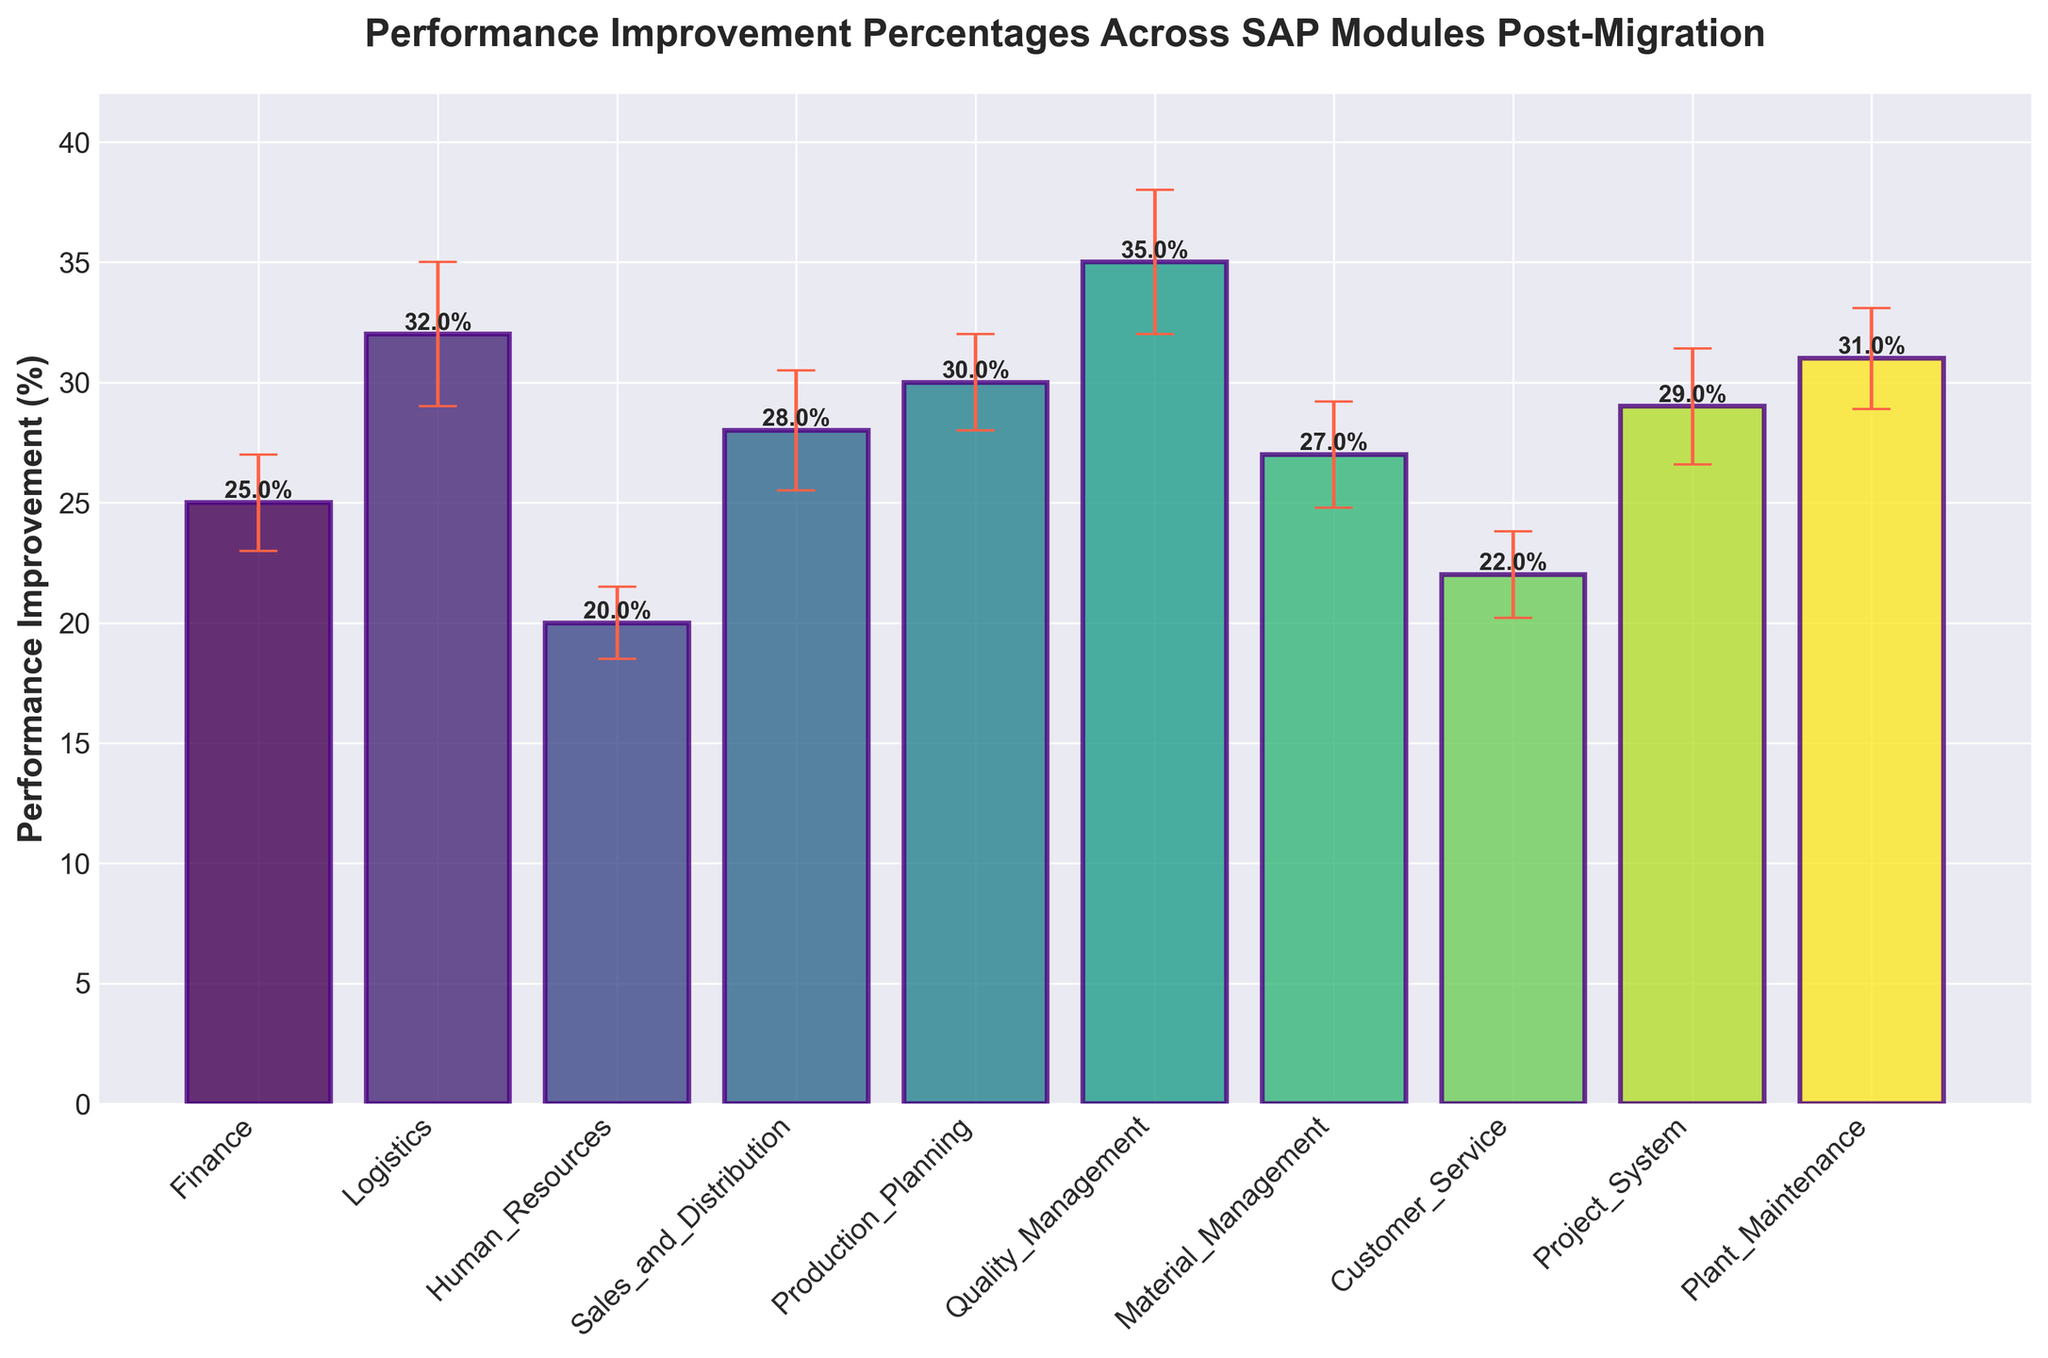Which SAP module has the highest performance improvement percentage post-migration? The highest performance improvement percentage can be identified by finding the tallest bar in the figure. The Quality Management module has the tallest bar.
Answer: Quality Management What is the performance improvement percentage for the Human Resources module? Find the bar labeled "Human Resources" and read the value at the top of the bar.
Answer: 20% What is the average performance improvement percentage across all SAP modules? Sum the performance improvement percentages of all modules and divide by the number of modules. ((25 + 32 + 20 + 28 + 30 + 35 + 27 + 22 + 29 + 31) / 10)
Answer: 27.9% Which module has a higher performance improvement: Finance or Customer Service? Compare the heights of the bars labeled "Finance" and "Customer Service." Finance has a higher bar.
Answer: Finance What is the range of error margins for the SAP modules? Identify the smallest and largest error margins in the figure. The smallest is 1.5 for Human Resources, and the largest is 3 for Logistics and Quality Management. The range is 3 - 1.5.
Answer: 1.5% How many modules have a performance improvement percentage above 30%? Count the number of bars with a height greater than 30%. Quality Management, Logistics, Production Planning, and Plant Maintenance all have performance above 30%.
Answer: 4 What is the difference in performance improvement percentages between Logistics and Sales and Distribution? Subtract the performance improvement percentage of Sales_and_Distribution from that of Logistics. 32% - 28% = 4%.
Answer: 4% Which module has the smallest error margin, and what is that value? Identify the bar with the smallest error bar. The Human Resources module has the smallest error margin at 1.5%.
Answer: Human Resources, 1.5% Is the performance improvement percentage for Material Management closer to that of Finance or Production Planning? Compare the difference in performance improvements: Material Management (27%) vs Finance (25%) is 2%, and Material Management (27%) vs Production Planning (30%) is 3%. Hence, Material Management is closer to Finance.
Answer: Finance Why is it important to include error margins in the performance improvement plot? Error margins indicate the uncertainty or variability in the measurement of performance improvement, providing a more accurate and reliable understanding of the data.
Answer: Indicates uncertainty 